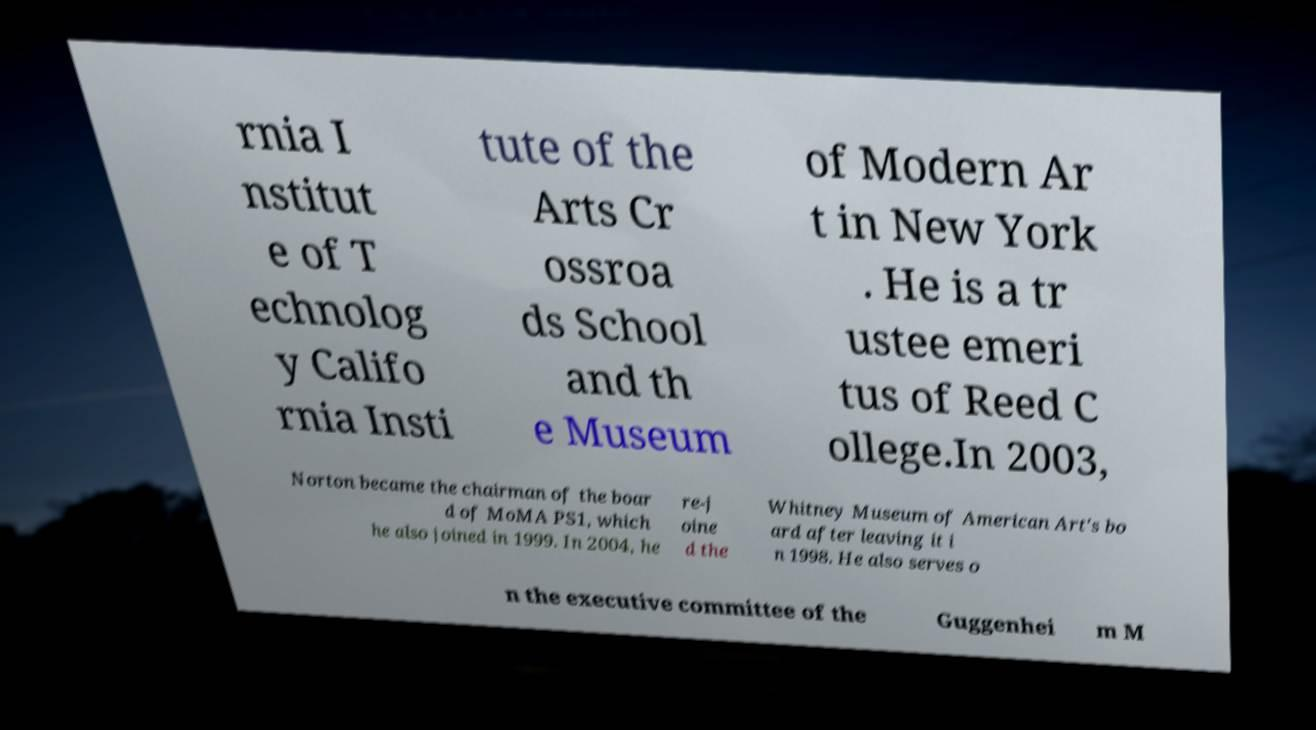What messages or text are displayed in this image? I need them in a readable, typed format. rnia I nstitut e of T echnolog y Califo rnia Insti tute of the Arts Cr ossroa ds School and th e Museum of Modern Ar t in New York . He is a tr ustee emeri tus of Reed C ollege.In 2003, Norton became the chairman of the boar d of MoMA PS1, which he also joined in 1999. In 2004, he re-j oine d the Whitney Museum of American Art's bo ard after leaving it i n 1998. He also serves o n the executive committee of the Guggenhei m M 